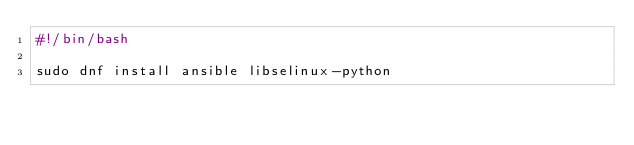Convert code to text. <code><loc_0><loc_0><loc_500><loc_500><_Bash_>#!/bin/bash

sudo dnf install ansible libselinux-python 
</code> 